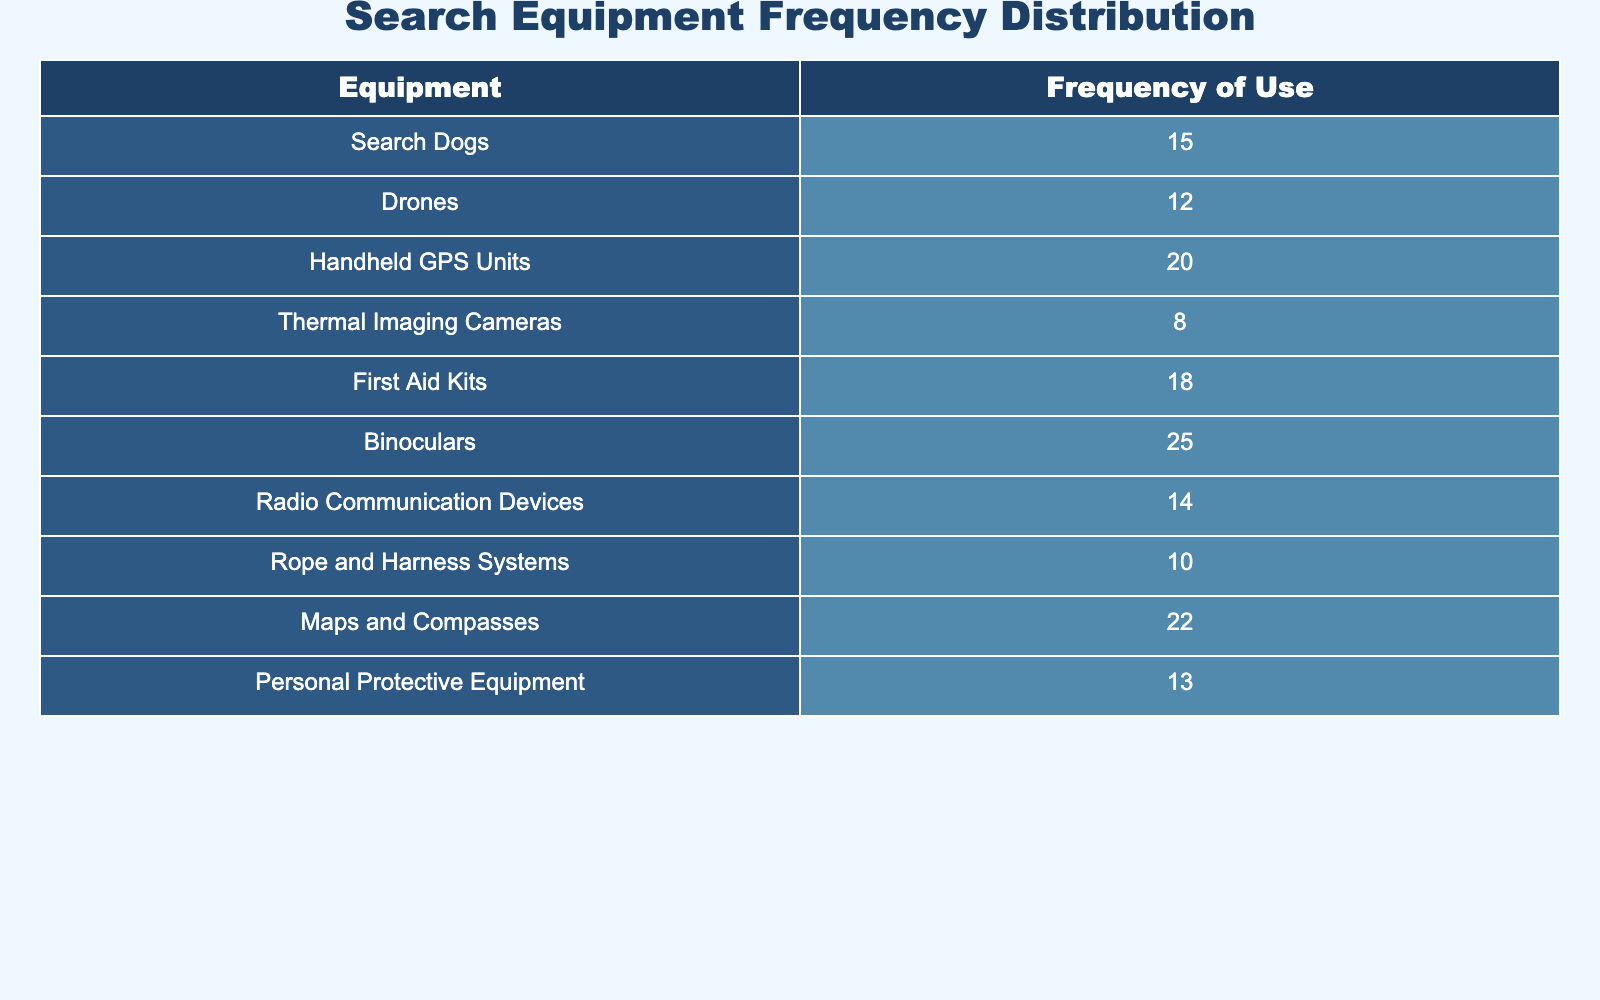What is the frequency of use for Search Dogs? Referring to the table, the frequency of use for Search Dogs is directly listed under the Frequency of Use column.
Answer: 15 Which equipment has the highest frequency of use? By comparing all the frequencies listed in the table, Binoculars have the highest frequency of use at 25.
Answer: Binoculars What is the total frequency of use for all equipment? To find the total frequency, sum all the frequencies listed: 15 + 12 + 20 + 8 + 18 + 25 + 14 + 10 + 22 + 13 =  122.
Answer: 122 Is the frequency of use for Thermal Imaging Cameras greater than that for Rope and Harness Systems? The frequency for Thermal Imaging Cameras is 8 while for Rope and Harness Systems it is 10. Since 8 is not greater than 10, the answer is no.
Answer: No What equipment is used more frequently: Drones or Radio Communication Devices? Drones have a frequency of 12 and Radio Communication Devices have a frequency of 14. Comparing these two values, Radio Communication Devices are used more frequently.
Answer: Radio Communication Devices What is the average frequency of use for the equipment listed? To calculate the average, first find the total frequency, which is 122, and then divide by the number of equipment types, which is 10: 122 / 10 = 12.2.
Answer: 12.2 Is the frequency of First Aid Kits greater than or equal to that of Personal Protective Equipment? The frequency for First Aid Kits is 18 and for Personal Protective Equipment, it is 13. Since 18 is greater than 13, the answer is yes.
Answer: Yes What equipment has more than 15 uses? From the table, equipment with more than 15 uses includes: Binoculars (25), Maps and Compasses (22), Handheld GPS Units (20), First Aid Kits (18).
Answer: Binoculars, Maps and Compasses, Handheld GPS Units, First Aid Kits 